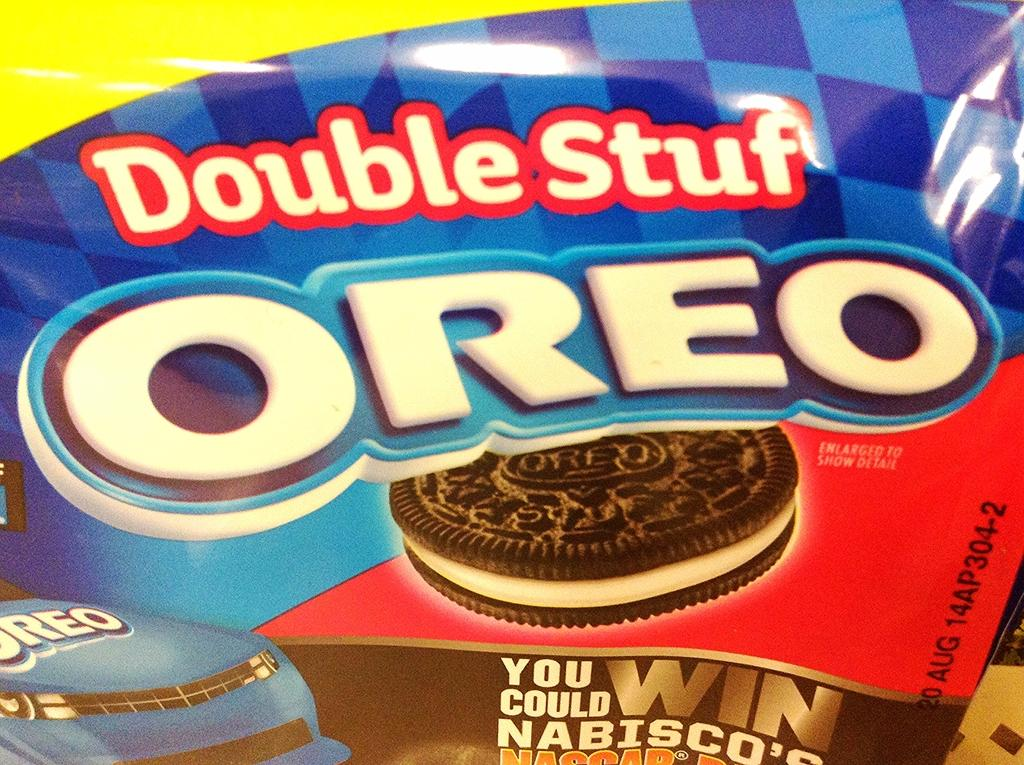What is the main object in the image? There is a plastic cover in the image. What can be seen on the plastic cover? There is printed text on the plastic cover. What type of food is visible in the image? There is a biscuit in the image. Can you tell me how many ducks are wearing vests in the image? There are no ducks or vests present in the image. Is there a boy holding a biscuit in the image? The provided facts do not mention a boy or any person holding the biscuit; only the biscuit itself is mentioned. 